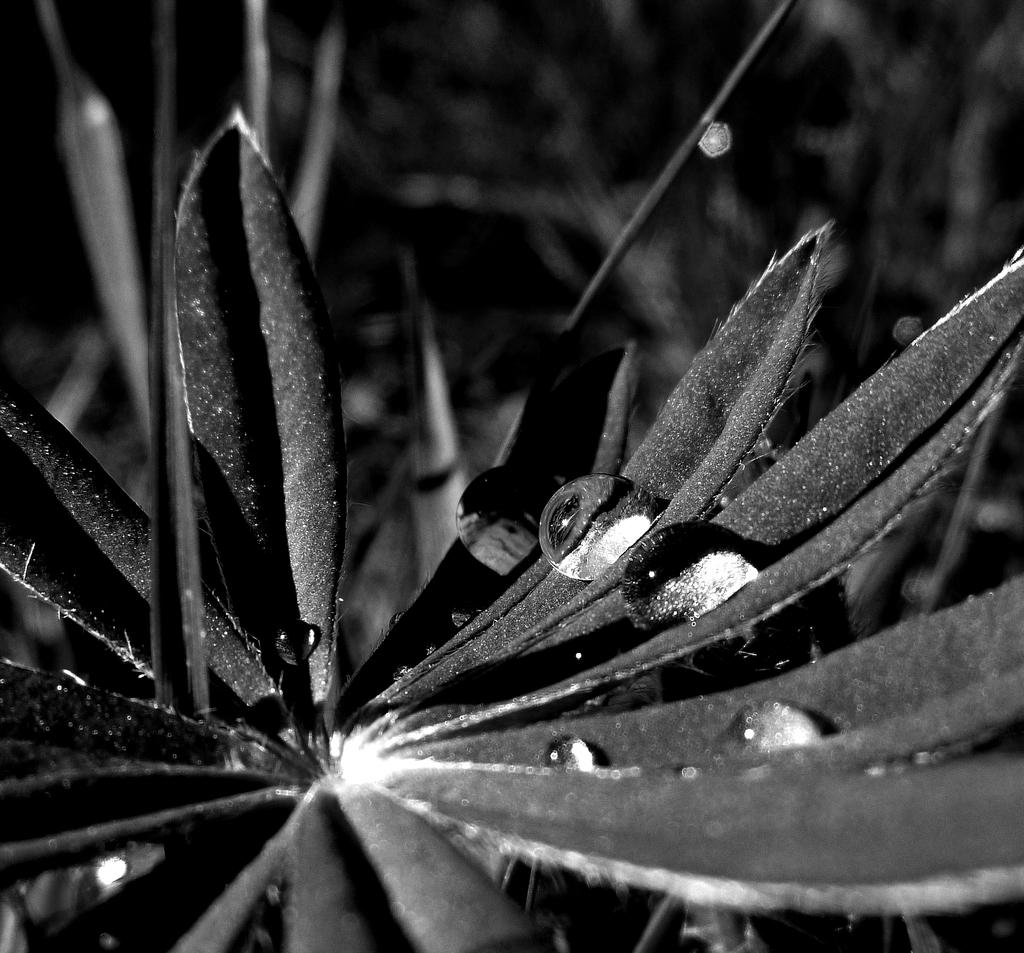What is the condition of the leaves on the flower in the image? There are water drops on the leaves of the flower in the image. How would you describe the background of the image? The background of the image is blurred. What color scheme is used in the image? The image is in black and white mode. Can you see any steam coming out of the cave in the image? There is no cave present in the image, so it is not possible to see any steam coming out of it. 